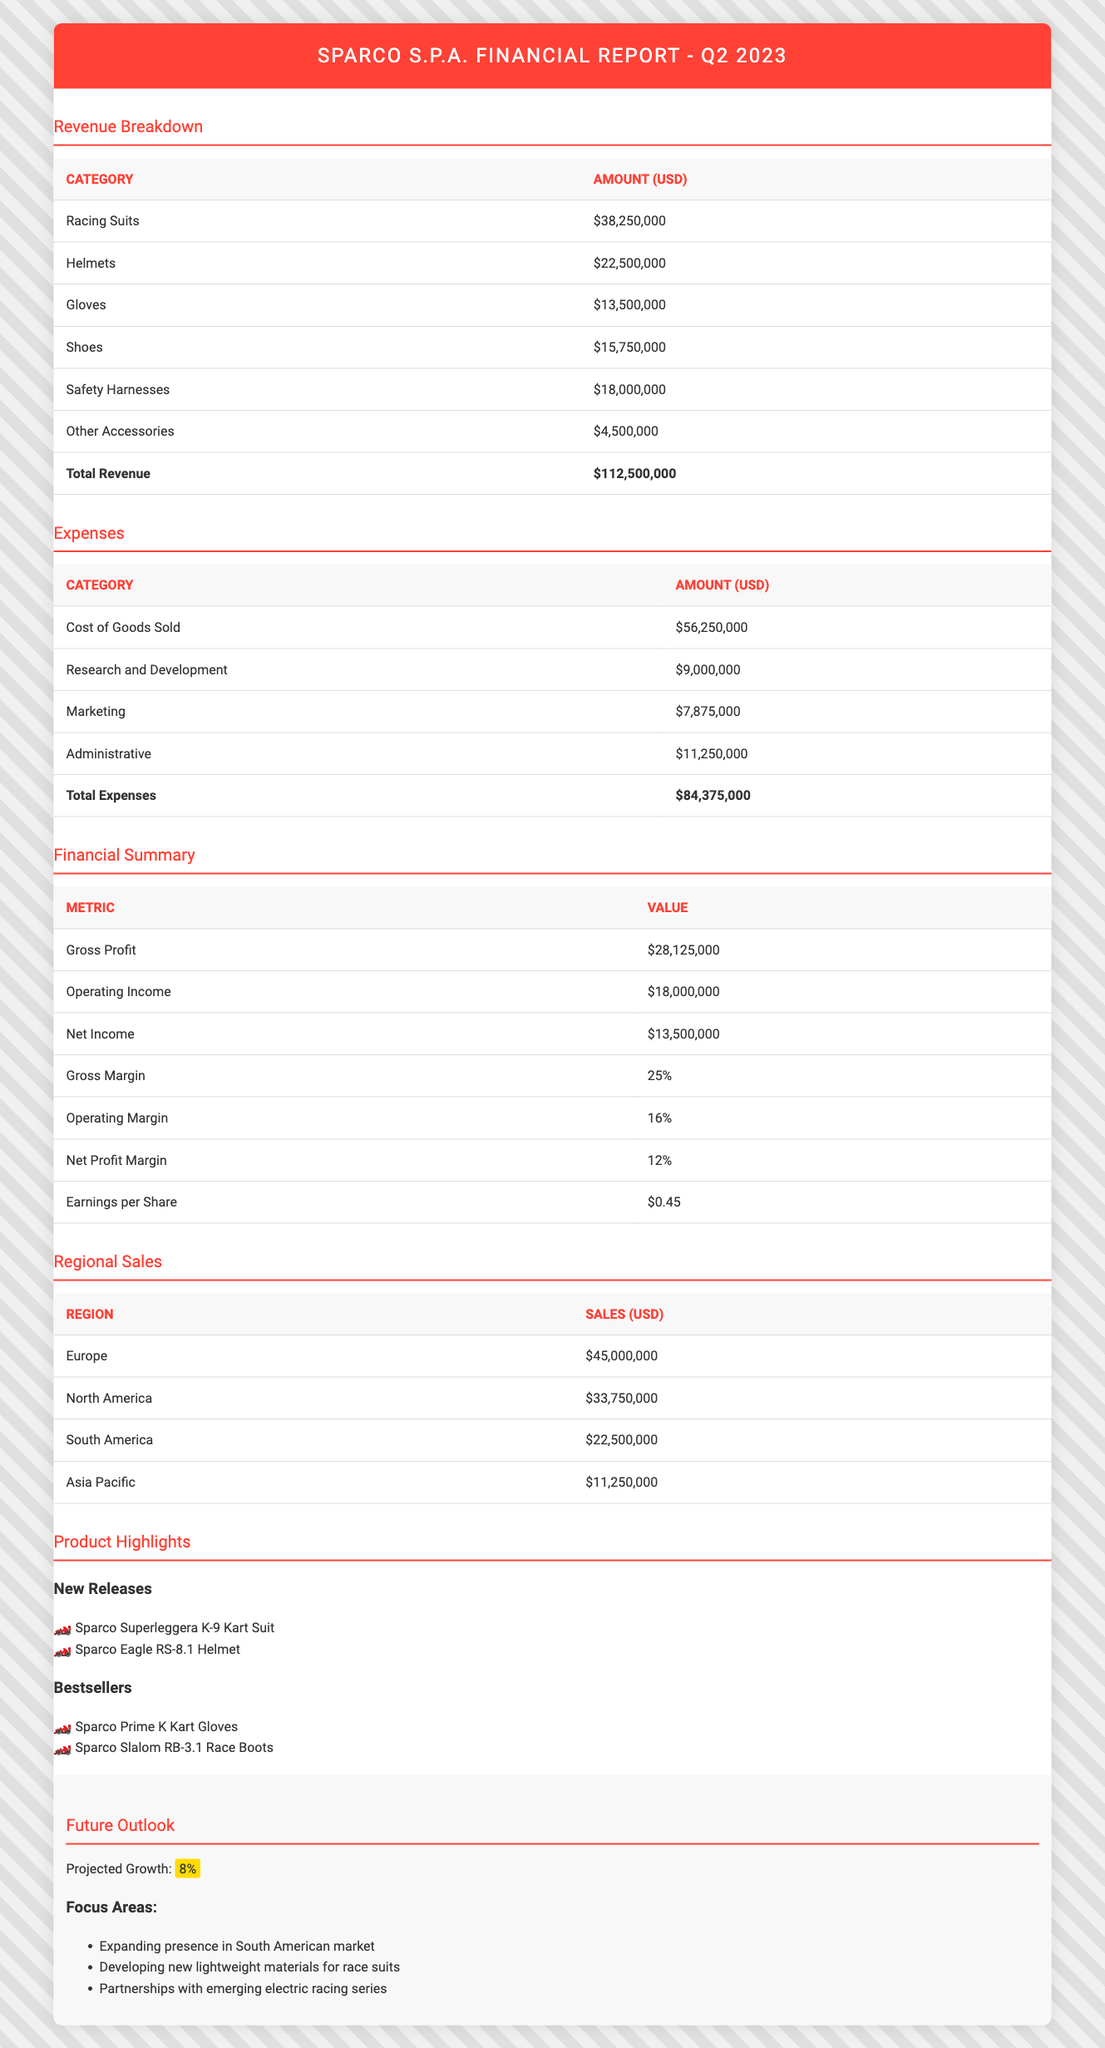What is the total revenue for Sparco S.p.A. in Q2 2023? The total revenue for Sparco S.p.A. is located in the Revenue Breakdown section of the table, which states that the total revenue is $112,500,000.
Answer: 112,500,000 What is the net income reported for the company? The net income is found in the Financial Summary section of the table, where it lists the net income as $13,500,000.
Answer: 13,500,000 Which product category generated the highest revenue? By examining the Revenue Breakdown table, Racing Suits have generated the highest revenue at $38,250,000, compared to other categories.
Answer: Racing Suits What are the total expenses incurred by Sparco S.p.A. in Q2 2023? The table shows that the total expenses sum up to $84,375,000, as noted in the Expenses section under Total Expenses.
Answer: 84,375,000 Is the gross profit margin greater than the operating profit margin? The gross margin is 25% and the operating margin is 16%. Since 25% is greater than 16%, the statement is true.
Answer: Yes What is the difference between total revenue and total expenses? To find the difference, subtract total expenses ($84,375,000) from total revenue ($112,500,000): $112,500,000 - $84,375,000 = $28,125,000.
Answer: 28,125,000 What percentage of total revenue does safety harnesses account for? To find the percentage, divide the revenue from safety harnesses ($18,000,000) by total revenue ($112,500,000), and then multiply by 100: ($18,000,000 / $112,500,000) * 100 = 16%.
Answer: 16% If the company projects an 8% growth, what will be the anticipated revenue in the next quarter? First, calculate the projected growth: 8% of the current total revenue ($112,500,000) is $9,000,000. Then, add this to the total revenue: $112,500,000 + $9,000,000 = $121,500,000.
Answer: 121,500,000 Are the net profit margin and earnings per share figures consistent with a profitable quarter? The net profit margin is 12%, and earnings per share is $0.45, which both indicate profitability, as positive margins and earnings reflect a profitable operation; therefore, the statement is true.
Answer: Yes 